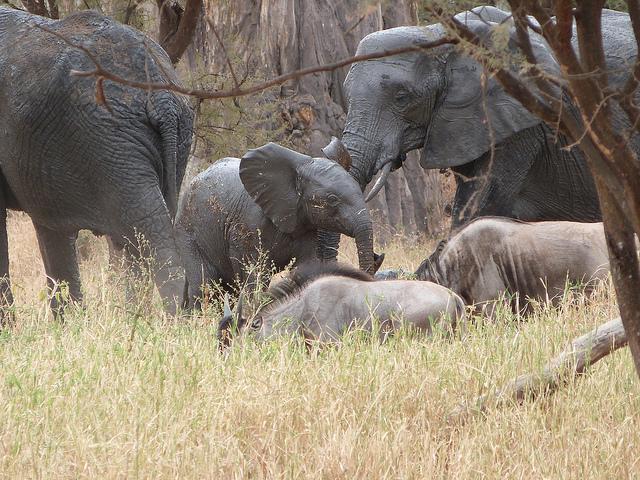What feature do these animals have?
Pick the correct solution from the four options below to address the question.
Options: Talons, wings, quills, trunks. Trunks. 